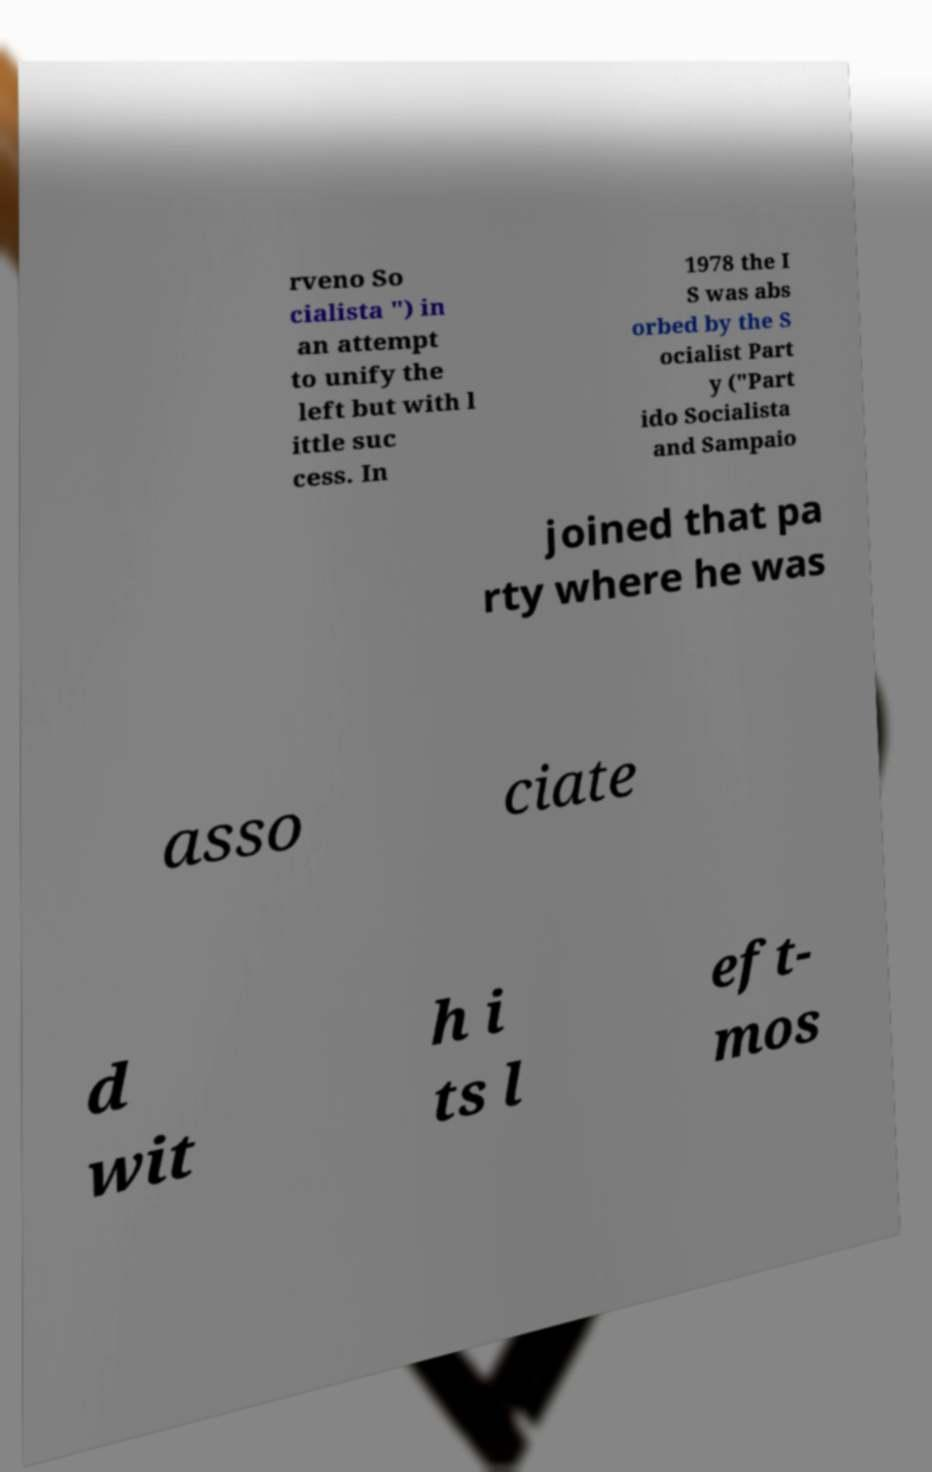Could you assist in decoding the text presented in this image and type it out clearly? rveno So cialista ") in an attempt to unify the left but with l ittle suc cess. In 1978 the I S was abs orbed by the S ocialist Part y ("Part ido Socialista and Sampaio joined that pa rty where he was asso ciate d wit h i ts l eft- mos 